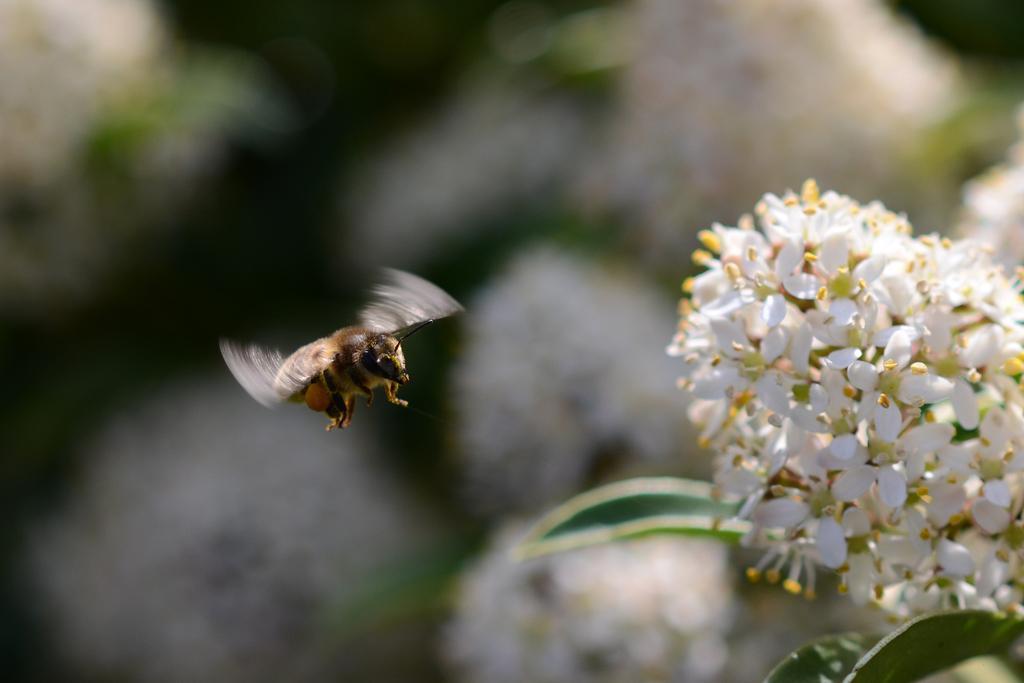How would you summarize this image in a sentence or two? In the picture we can see some group of flowers which are white in color and near to it, we can see a bee is flying and behind it we can see some plants with flowers which are not clearly visible. 